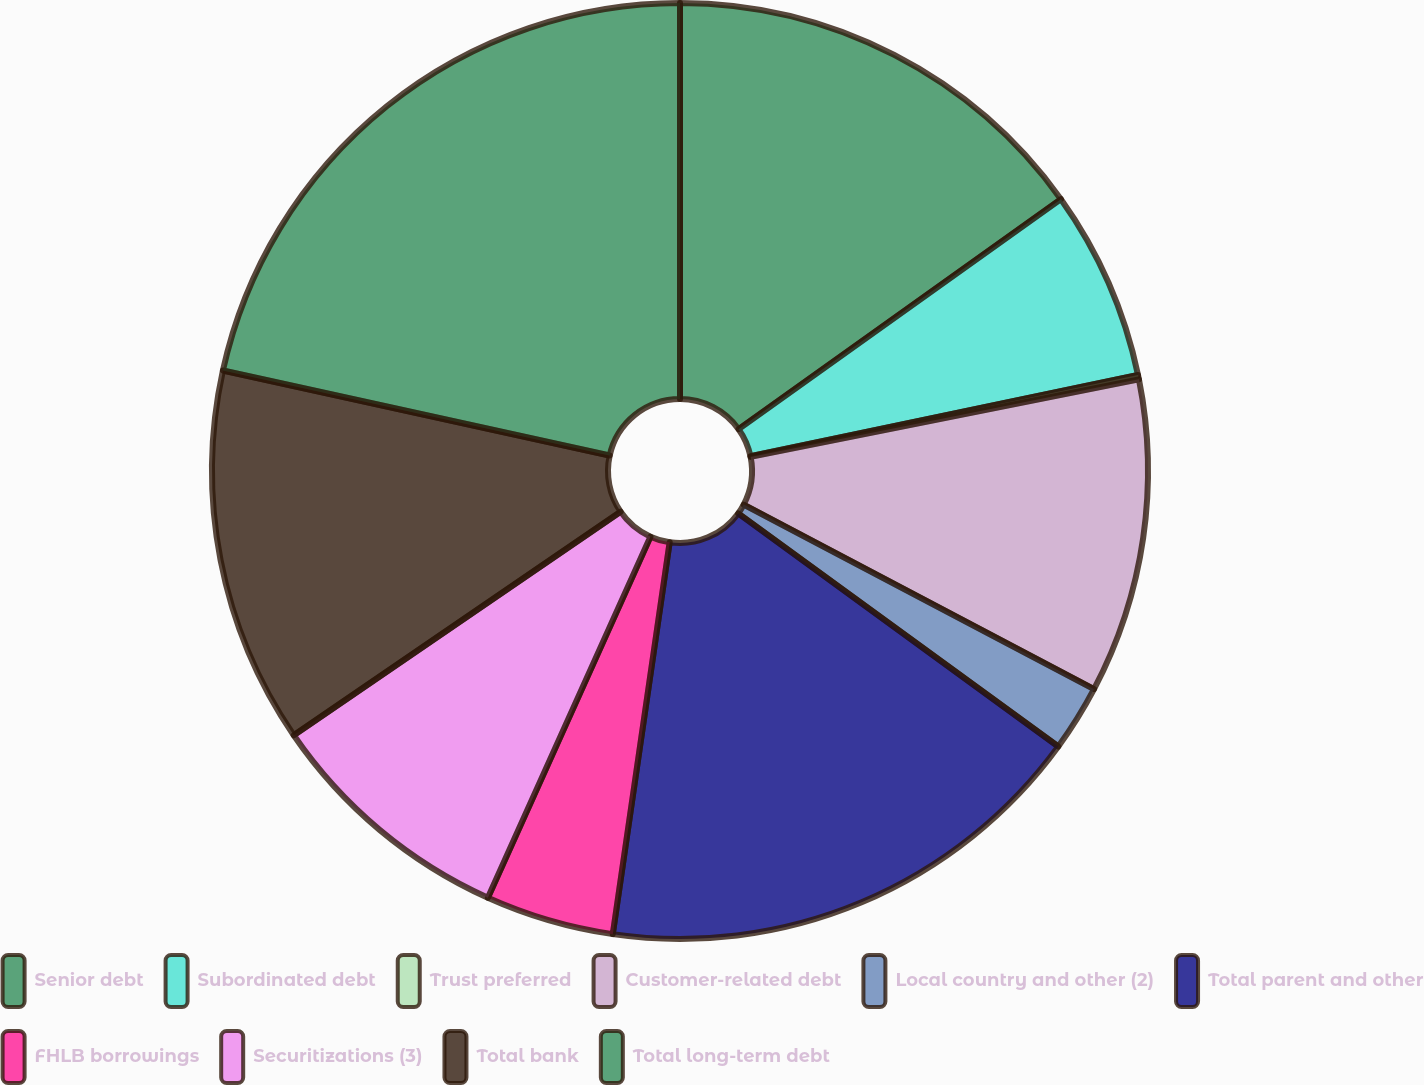Convert chart. <chart><loc_0><loc_0><loc_500><loc_500><pie_chart><fcel>Senior debt<fcel>Subordinated debt<fcel>Trust preferred<fcel>Customer-related debt<fcel>Local country and other (2)<fcel>Total parent and other<fcel>FHLB borrowings<fcel>Securitizations (3)<fcel>Total bank<fcel>Total long-term debt<nl><fcel>15.14%<fcel>6.58%<fcel>0.15%<fcel>10.86%<fcel>2.3%<fcel>17.28%<fcel>4.44%<fcel>8.72%<fcel>13.0%<fcel>21.56%<nl></chart> 